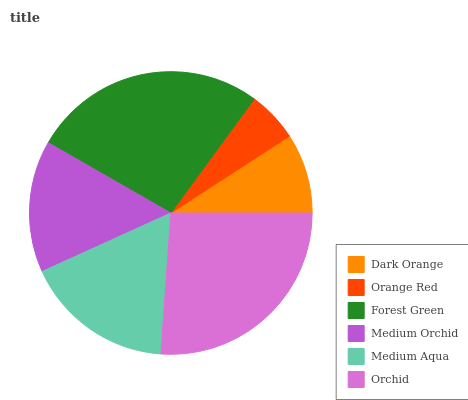Is Orange Red the minimum?
Answer yes or no. Yes. Is Forest Green the maximum?
Answer yes or no. Yes. Is Forest Green the minimum?
Answer yes or no. No. Is Orange Red the maximum?
Answer yes or no. No. Is Forest Green greater than Orange Red?
Answer yes or no. Yes. Is Orange Red less than Forest Green?
Answer yes or no. Yes. Is Orange Red greater than Forest Green?
Answer yes or no. No. Is Forest Green less than Orange Red?
Answer yes or no. No. Is Medium Aqua the high median?
Answer yes or no. Yes. Is Medium Orchid the low median?
Answer yes or no. Yes. Is Dark Orange the high median?
Answer yes or no. No. Is Orchid the low median?
Answer yes or no. No. 